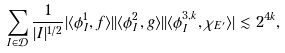<formula> <loc_0><loc_0><loc_500><loc_500>\sum _ { I \in \mathcal { D } } \frac { 1 } { | I | ^ { 1 / 2 } } | \langle \phi _ { I } ^ { 1 } , f \rangle | | \langle \phi _ { I } ^ { 2 } , g \rangle | | \langle \phi _ { I } ^ { 3 , k } , \chi _ { E ^ { \prime } } \rangle | \lesssim 2 ^ { 4 k } ,</formula> 